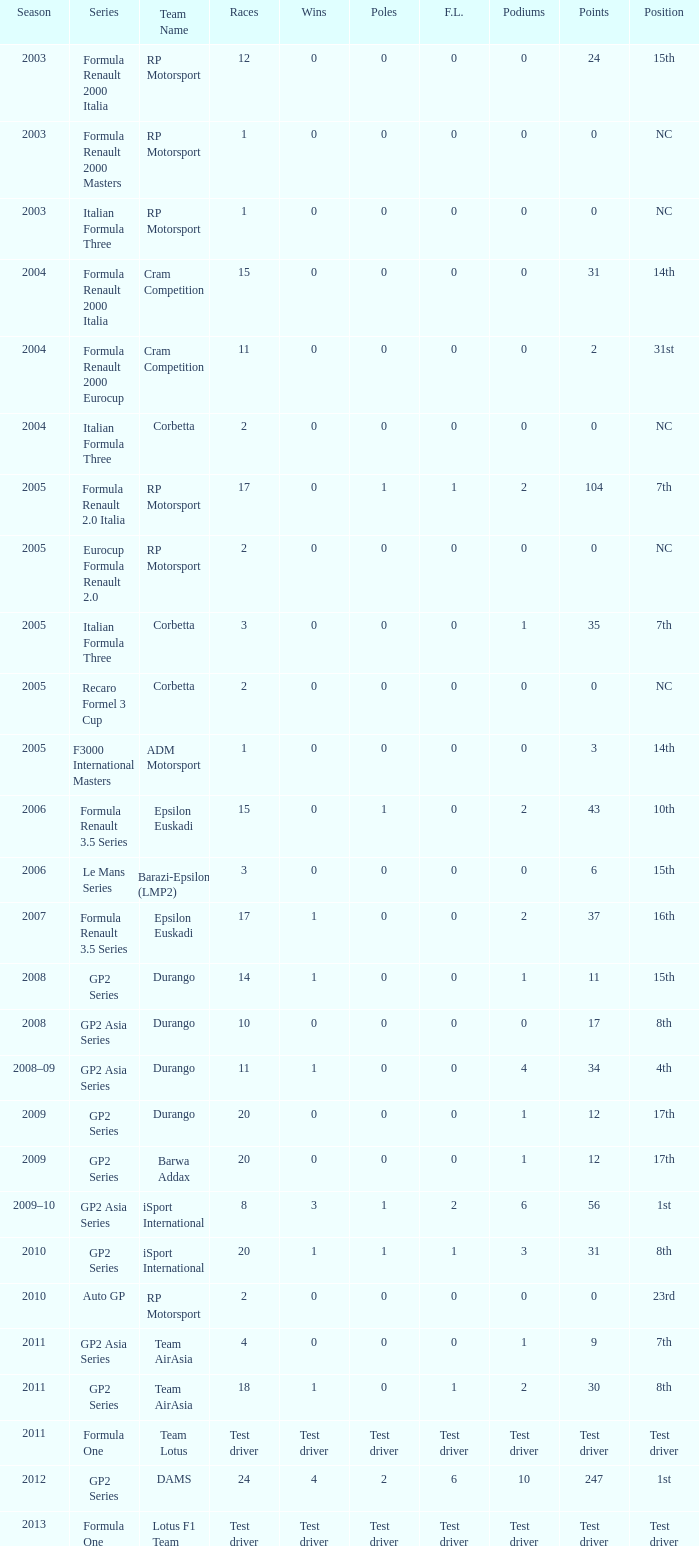Which competitions feature gp2 series, 0 f.l., and a 17th place finish? 20, 20. Would you mind parsing the complete table? {'header': ['Season', 'Series', 'Team Name', 'Races', 'Wins', 'Poles', 'F.L.', 'Podiums', 'Points', 'Position'], 'rows': [['2003', 'Formula Renault 2000 Italia', 'RP Motorsport', '12', '0', '0', '0', '0', '24', '15th'], ['2003', 'Formula Renault 2000 Masters', 'RP Motorsport', '1', '0', '0', '0', '0', '0', 'NC'], ['2003', 'Italian Formula Three', 'RP Motorsport', '1', '0', '0', '0', '0', '0', 'NC'], ['2004', 'Formula Renault 2000 Italia', 'Cram Competition', '15', '0', '0', '0', '0', '31', '14th'], ['2004', 'Formula Renault 2000 Eurocup', 'Cram Competition', '11', '0', '0', '0', '0', '2', '31st'], ['2004', 'Italian Formula Three', 'Corbetta', '2', '0', '0', '0', '0', '0', 'NC'], ['2005', 'Formula Renault 2.0 Italia', 'RP Motorsport', '17', '0', '1', '1', '2', '104', '7th'], ['2005', 'Eurocup Formula Renault 2.0', 'RP Motorsport', '2', '0', '0', '0', '0', '0', 'NC'], ['2005', 'Italian Formula Three', 'Corbetta', '3', '0', '0', '0', '1', '35', '7th'], ['2005', 'Recaro Formel 3 Cup', 'Corbetta', '2', '0', '0', '0', '0', '0', 'NC'], ['2005', 'F3000 International Masters', 'ADM Motorsport', '1', '0', '0', '0', '0', '3', '14th'], ['2006', 'Formula Renault 3.5 Series', 'Epsilon Euskadi', '15', '0', '1', '0', '2', '43', '10th'], ['2006', 'Le Mans Series', 'Barazi-Epsilon (LMP2)', '3', '0', '0', '0', '0', '6', '15th'], ['2007', 'Formula Renault 3.5 Series', 'Epsilon Euskadi', '17', '1', '0', '0', '2', '37', '16th'], ['2008', 'GP2 Series', 'Durango', '14', '1', '0', '0', '1', '11', '15th'], ['2008', 'GP2 Asia Series', 'Durango', '10', '0', '0', '0', '0', '17', '8th'], ['2008–09', 'GP2 Asia Series', 'Durango', '11', '1', '0', '0', '4', '34', '4th'], ['2009', 'GP2 Series', 'Durango', '20', '0', '0', '0', '1', '12', '17th'], ['2009', 'GP2 Series', 'Barwa Addax', '20', '0', '0', '0', '1', '12', '17th'], ['2009–10', 'GP2 Asia Series', 'iSport International', '8', '3', '1', '2', '6', '56', '1st'], ['2010', 'GP2 Series', 'iSport International', '20', '1', '1', '1', '3', '31', '8th'], ['2010', 'Auto GP', 'RP Motorsport', '2', '0', '0', '0', '0', '0', '23rd'], ['2011', 'GP2 Asia Series', 'Team AirAsia', '4', '0', '0', '0', '1', '9', '7th'], ['2011', 'GP2 Series', 'Team AirAsia', '18', '1', '0', '1', '2', '30', '8th'], ['2011', 'Formula One', 'Team Lotus', 'Test driver', 'Test driver', 'Test driver', 'Test driver', 'Test driver', 'Test driver', 'Test driver'], ['2012', 'GP2 Series', 'DAMS', '24', '4', '2', '6', '10', '247', '1st'], ['2013', 'Formula One', 'Lotus F1 Team', 'Test driver', 'Test driver', 'Test driver', 'Test driver', 'Test driver', 'Test driver', 'Test driver']]} 